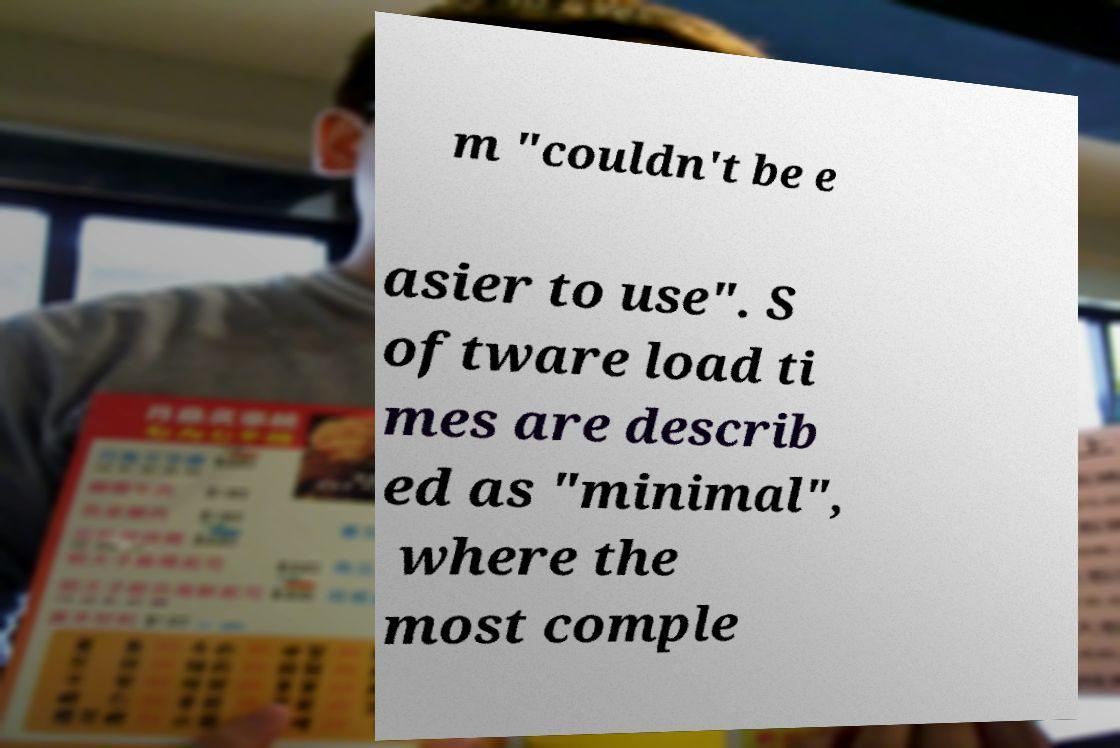Can you read and provide the text displayed in the image?This photo seems to have some interesting text. Can you extract and type it out for me? m "couldn't be e asier to use". S oftware load ti mes are describ ed as "minimal", where the most comple 